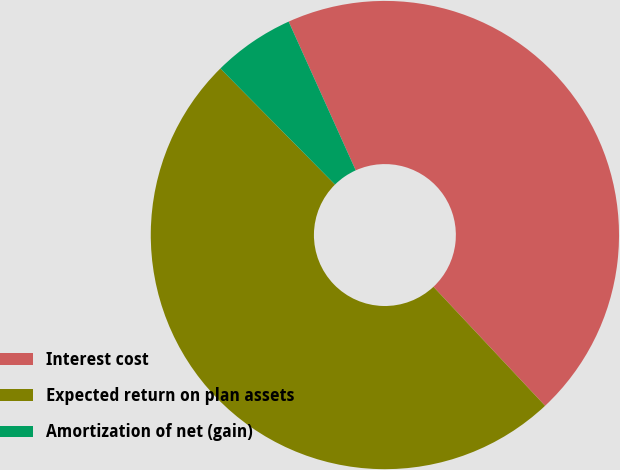Convert chart to OTSL. <chart><loc_0><loc_0><loc_500><loc_500><pie_chart><fcel>Interest cost<fcel>Expected return on plan assets<fcel>Amortization of net (gain)<nl><fcel>44.75%<fcel>49.59%<fcel>5.66%<nl></chart> 